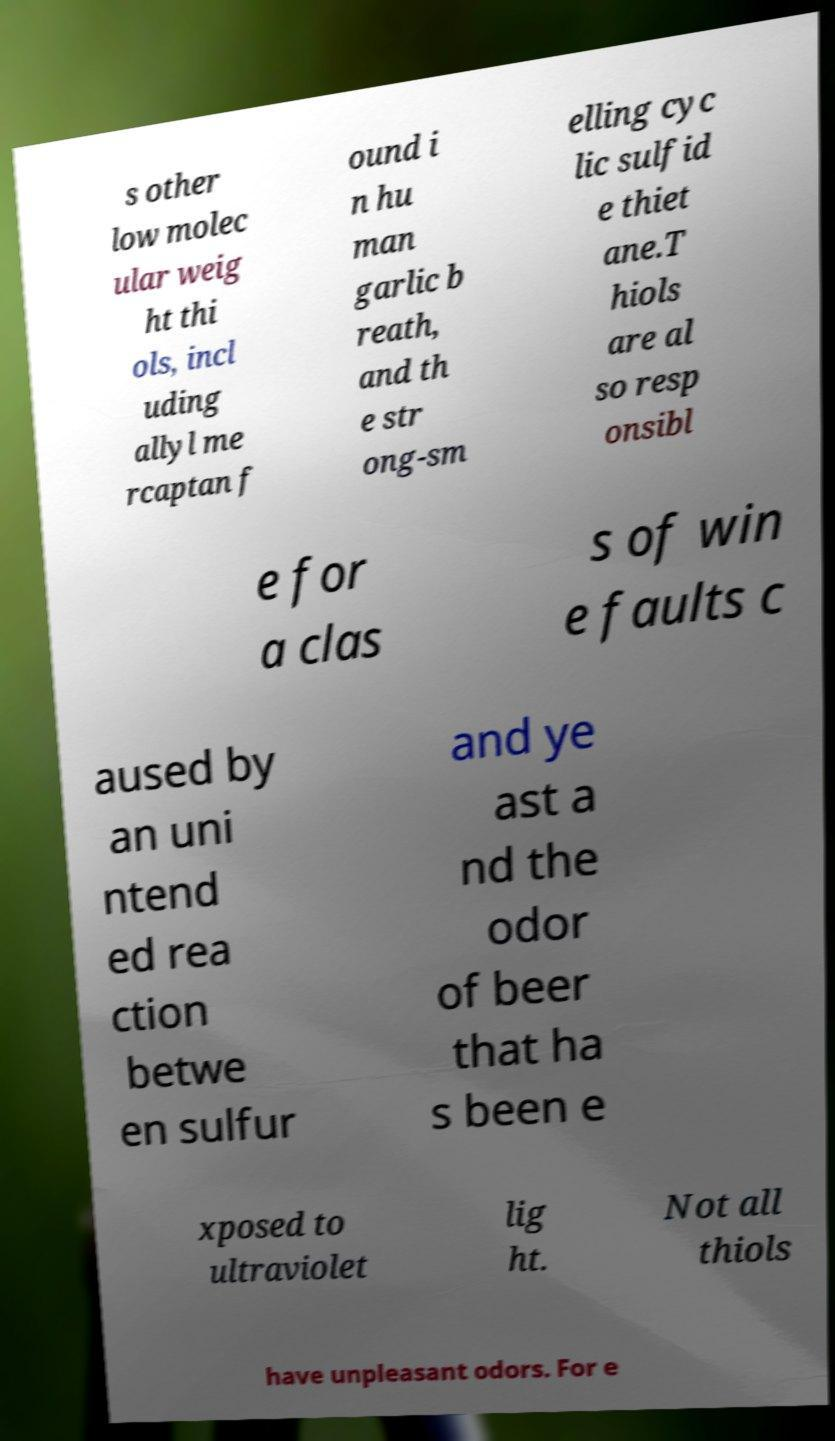What messages or text are displayed in this image? I need them in a readable, typed format. s other low molec ular weig ht thi ols, incl uding allyl me rcaptan f ound i n hu man garlic b reath, and th e str ong-sm elling cyc lic sulfid e thiet ane.T hiols are al so resp onsibl e for a clas s of win e faults c aused by an uni ntend ed rea ction betwe en sulfur and ye ast a nd the odor of beer that ha s been e xposed to ultraviolet lig ht. Not all thiols have unpleasant odors. For e 